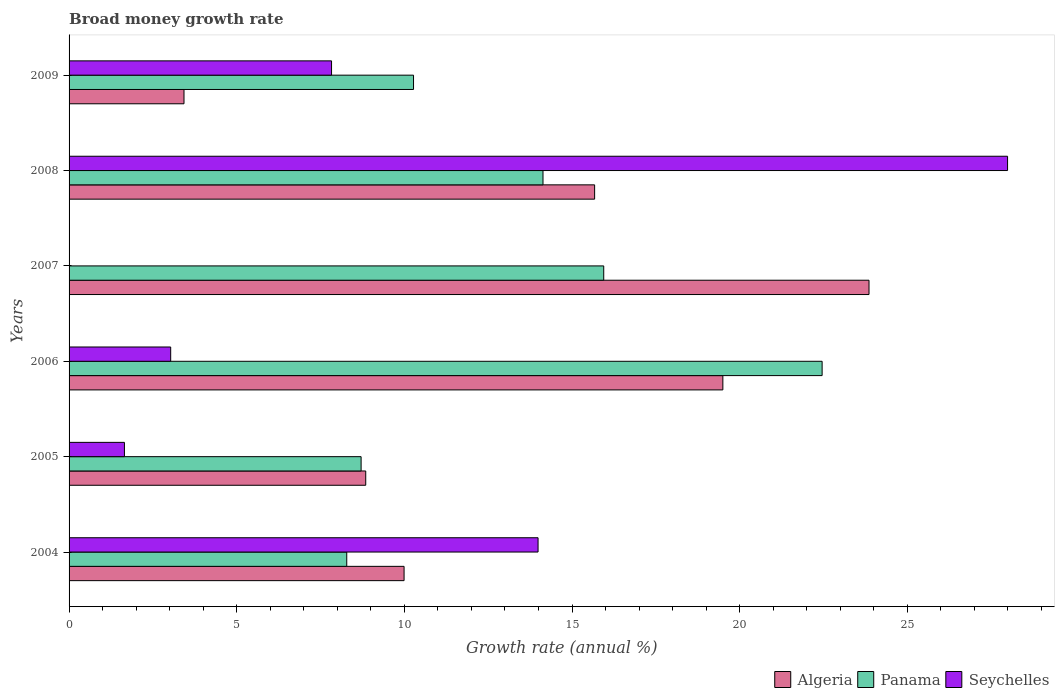How many different coloured bars are there?
Provide a succinct answer. 3. Are the number of bars per tick equal to the number of legend labels?
Your response must be concise. No. How many bars are there on the 3rd tick from the top?
Provide a succinct answer. 2. How many bars are there on the 4th tick from the bottom?
Provide a succinct answer. 2. What is the growth rate in Algeria in 2008?
Your answer should be very brief. 15.67. Across all years, what is the maximum growth rate in Panama?
Give a very brief answer. 22.46. Across all years, what is the minimum growth rate in Seychelles?
Your answer should be compact. 0. In which year was the growth rate in Panama maximum?
Ensure brevity in your answer.  2006. What is the total growth rate in Panama in the graph?
Ensure brevity in your answer.  79.8. What is the difference between the growth rate in Algeria in 2005 and that in 2009?
Offer a terse response. 5.42. What is the difference between the growth rate in Algeria in 2005 and the growth rate in Seychelles in 2007?
Your answer should be very brief. 8.85. What is the average growth rate in Panama per year?
Keep it short and to the point. 13.3. In the year 2005, what is the difference between the growth rate in Seychelles and growth rate in Algeria?
Ensure brevity in your answer.  -7.2. What is the ratio of the growth rate in Algeria in 2004 to that in 2007?
Make the answer very short. 0.42. Is the growth rate in Seychelles in 2004 less than that in 2009?
Your response must be concise. No. Is the difference between the growth rate in Seychelles in 2004 and 2005 greater than the difference between the growth rate in Algeria in 2004 and 2005?
Your answer should be compact. Yes. What is the difference between the highest and the second highest growth rate in Panama?
Your answer should be very brief. 6.51. What is the difference between the highest and the lowest growth rate in Algeria?
Your answer should be very brief. 20.43. Is it the case that in every year, the sum of the growth rate in Seychelles and growth rate in Panama is greater than the growth rate in Algeria?
Keep it short and to the point. No. Are all the bars in the graph horizontal?
Your answer should be compact. Yes. How many years are there in the graph?
Your answer should be very brief. 6. Are the values on the major ticks of X-axis written in scientific E-notation?
Offer a terse response. No. Does the graph contain any zero values?
Offer a very short reply. Yes. How are the legend labels stacked?
Keep it short and to the point. Horizontal. What is the title of the graph?
Offer a terse response. Broad money growth rate. What is the label or title of the X-axis?
Keep it short and to the point. Growth rate (annual %). What is the Growth rate (annual %) of Algeria in 2004?
Your response must be concise. 9.99. What is the Growth rate (annual %) in Panama in 2004?
Your answer should be compact. 8.28. What is the Growth rate (annual %) in Seychelles in 2004?
Your answer should be very brief. 13.99. What is the Growth rate (annual %) of Algeria in 2005?
Keep it short and to the point. 8.85. What is the Growth rate (annual %) in Panama in 2005?
Your response must be concise. 8.71. What is the Growth rate (annual %) of Seychelles in 2005?
Provide a short and direct response. 1.65. What is the Growth rate (annual %) of Algeria in 2006?
Provide a short and direct response. 19.5. What is the Growth rate (annual %) of Panama in 2006?
Your answer should be compact. 22.46. What is the Growth rate (annual %) of Seychelles in 2006?
Your response must be concise. 3.03. What is the Growth rate (annual %) in Algeria in 2007?
Ensure brevity in your answer.  23.86. What is the Growth rate (annual %) in Panama in 2007?
Keep it short and to the point. 15.95. What is the Growth rate (annual %) in Seychelles in 2007?
Offer a terse response. 0. What is the Growth rate (annual %) in Algeria in 2008?
Offer a terse response. 15.67. What is the Growth rate (annual %) in Panama in 2008?
Your answer should be very brief. 14.13. What is the Growth rate (annual %) in Seychelles in 2008?
Your answer should be compact. 27.99. What is the Growth rate (annual %) in Algeria in 2009?
Your answer should be very brief. 3.43. What is the Growth rate (annual %) of Panama in 2009?
Make the answer very short. 10.27. What is the Growth rate (annual %) of Seychelles in 2009?
Offer a terse response. 7.83. Across all years, what is the maximum Growth rate (annual %) in Algeria?
Give a very brief answer. 23.86. Across all years, what is the maximum Growth rate (annual %) of Panama?
Keep it short and to the point. 22.46. Across all years, what is the maximum Growth rate (annual %) in Seychelles?
Make the answer very short. 27.99. Across all years, what is the minimum Growth rate (annual %) in Algeria?
Your response must be concise. 3.43. Across all years, what is the minimum Growth rate (annual %) in Panama?
Give a very brief answer. 8.28. Across all years, what is the minimum Growth rate (annual %) of Seychelles?
Provide a succinct answer. 0. What is the total Growth rate (annual %) of Algeria in the graph?
Make the answer very short. 81.29. What is the total Growth rate (annual %) in Panama in the graph?
Ensure brevity in your answer.  79.8. What is the total Growth rate (annual %) in Seychelles in the graph?
Your answer should be compact. 54.49. What is the difference between the Growth rate (annual %) of Algeria in 2004 and that in 2005?
Offer a very short reply. 1.14. What is the difference between the Growth rate (annual %) in Panama in 2004 and that in 2005?
Keep it short and to the point. -0.43. What is the difference between the Growth rate (annual %) in Seychelles in 2004 and that in 2005?
Ensure brevity in your answer.  12.34. What is the difference between the Growth rate (annual %) of Algeria in 2004 and that in 2006?
Keep it short and to the point. -9.51. What is the difference between the Growth rate (annual %) of Panama in 2004 and that in 2006?
Keep it short and to the point. -14.18. What is the difference between the Growth rate (annual %) of Seychelles in 2004 and that in 2006?
Your response must be concise. 10.96. What is the difference between the Growth rate (annual %) in Algeria in 2004 and that in 2007?
Your response must be concise. -13.87. What is the difference between the Growth rate (annual %) of Panama in 2004 and that in 2007?
Keep it short and to the point. -7.66. What is the difference between the Growth rate (annual %) of Algeria in 2004 and that in 2008?
Make the answer very short. -5.68. What is the difference between the Growth rate (annual %) of Panama in 2004 and that in 2008?
Provide a short and direct response. -5.85. What is the difference between the Growth rate (annual %) in Seychelles in 2004 and that in 2008?
Offer a terse response. -14. What is the difference between the Growth rate (annual %) of Algeria in 2004 and that in 2009?
Keep it short and to the point. 6.56. What is the difference between the Growth rate (annual %) of Panama in 2004 and that in 2009?
Make the answer very short. -1.99. What is the difference between the Growth rate (annual %) of Seychelles in 2004 and that in 2009?
Provide a short and direct response. 6.16. What is the difference between the Growth rate (annual %) in Algeria in 2005 and that in 2006?
Your answer should be very brief. -10.65. What is the difference between the Growth rate (annual %) of Panama in 2005 and that in 2006?
Provide a short and direct response. -13.75. What is the difference between the Growth rate (annual %) of Seychelles in 2005 and that in 2006?
Provide a succinct answer. -1.38. What is the difference between the Growth rate (annual %) of Algeria in 2005 and that in 2007?
Offer a very short reply. -15.01. What is the difference between the Growth rate (annual %) of Panama in 2005 and that in 2007?
Your answer should be compact. -7.24. What is the difference between the Growth rate (annual %) of Algeria in 2005 and that in 2008?
Ensure brevity in your answer.  -6.83. What is the difference between the Growth rate (annual %) in Panama in 2005 and that in 2008?
Give a very brief answer. -5.42. What is the difference between the Growth rate (annual %) of Seychelles in 2005 and that in 2008?
Ensure brevity in your answer.  -26.34. What is the difference between the Growth rate (annual %) in Algeria in 2005 and that in 2009?
Offer a terse response. 5.42. What is the difference between the Growth rate (annual %) of Panama in 2005 and that in 2009?
Your answer should be very brief. -1.56. What is the difference between the Growth rate (annual %) in Seychelles in 2005 and that in 2009?
Keep it short and to the point. -6.18. What is the difference between the Growth rate (annual %) of Algeria in 2006 and that in 2007?
Your response must be concise. -4.36. What is the difference between the Growth rate (annual %) of Panama in 2006 and that in 2007?
Your answer should be compact. 6.51. What is the difference between the Growth rate (annual %) of Algeria in 2006 and that in 2008?
Your answer should be compact. 3.82. What is the difference between the Growth rate (annual %) in Panama in 2006 and that in 2008?
Offer a very short reply. 8.32. What is the difference between the Growth rate (annual %) of Seychelles in 2006 and that in 2008?
Your answer should be very brief. -24.96. What is the difference between the Growth rate (annual %) of Algeria in 2006 and that in 2009?
Your answer should be compact. 16.07. What is the difference between the Growth rate (annual %) in Panama in 2006 and that in 2009?
Ensure brevity in your answer.  12.19. What is the difference between the Growth rate (annual %) in Seychelles in 2006 and that in 2009?
Your answer should be compact. -4.8. What is the difference between the Growth rate (annual %) of Algeria in 2007 and that in 2008?
Your response must be concise. 8.18. What is the difference between the Growth rate (annual %) of Panama in 2007 and that in 2008?
Your response must be concise. 1.81. What is the difference between the Growth rate (annual %) in Algeria in 2007 and that in 2009?
Make the answer very short. 20.43. What is the difference between the Growth rate (annual %) of Panama in 2007 and that in 2009?
Offer a very short reply. 5.67. What is the difference between the Growth rate (annual %) of Algeria in 2008 and that in 2009?
Offer a terse response. 12.25. What is the difference between the Growth rate (annual %) of Panama in 2008 and that in 2009?
Your answer should be compact. 3.86. What is the difference between the Growth rate (annual %) in Seychelles in 2008 and that in 2009?
Give a very brief answer. 20.16. What is the difference between the Growth rate (annual %) of Algeria in 2004 and the Growth rate (annual %) of Panama in 2005?
Your answer should be compact. 1.28. What is the difference between the Growth rate (annual %) in Algeria in 2004 and the Growth rate (annual %) in Seychelles in 2005?
Keep it short and to the point. 8.34. What is the difference between the Growth rate (annual %) of Panama in 2004 and the Growth rate (annual %) of Seychelles in 2005?
Your answer should be very brief. 6.63. What is the difference between the Growth rate (annual %) in Algeria in 2004 and the Growth rate (annual %) in Panama in 2006?
Provide a short and direct response. -12.47. What is the difference between the Growth rate (annual %) in Algeria in 2004 and the Growth rate (annual %) in Seychelles in 2006?
Give a very brief answer. 6.96. What is the difference between the Growth rate (annual %) of Panama in 2004 and the Growth rate (annual %) of Seychelles in 2006?
Offer a terse response. 5.25. What is the difference between the Growth rate (annual %) of Algeria in 2004 and the Growth rate (annual %) of Panama in 2007?
Your answer should be very brief. -5.95. What is the difference between the Growth rate (annual %) in Algeria in 2004 and the Growth rate (annual %) in Panama in 2008?
Make the answer very short. -4.14. What is the difference between the Growth rate (annual %) of Algeria in 2004 and the Growth rate (annual %) of Seychelles in 2008?
Your response must be concise. -18. What is the difference between the Growth rate (annual %) in Panama in 2004 and the Growth rate (annual %) in Seychelles in 2008?
Keep it short and to the point. -19.71. What is the difference between the Growth rate (annual %) of Algeria in 2004 and the Growth rate (annual %) of Panama in 2009?
Ensure brevity in your answer.  -0.28. What is the difference between the Growth rate (annual %) in Algeria in 2004 and the Growth rate (annual %) in Seychelles in 2009?
Your answer should be compact. 2.16. What is the difference between the Growth rate (annual %) of Panama in 2004 and the Growth rate (annual %) of Seychelles in 2009?
Your answer should be very brief. 0.45. What is the difference between the Growth rate (annual %) in Algeria in 2005 and the Growth rate (annual %) in Panama in 2006?
Make the answer very short. -13.61. What is the difference between the Growth rate (annual %) of Algeria in 2005 and the Growth rate (annual %) of Seychelles in 2006?
Make the answer very short. 5.82. What is the difference between the Growth rate (annual %) of Panama in 2005 and the Growth rate (annual %) of Seychelles in 2006?
Provide a short and direct response. 5.68. What is the difference between the Growth rate (annual %) of Algeria in 2005 and the Growth rate (annual %) of Panama in 2007?
Keep it short and to the point. -7.1. What is the difference between the Growth rate (annual %) of Algeria in 2005 and the Growth rate (annual %) of Panama in 2008?
Offer a terse response. -5.29. What is the difference between the Growth rate (annual %) of Algeria in 2005 and the Growth rate (annual %) of Seychelles in 2008?
Ensure brevity in your answer.  -19.14. What is the difference between the Growth rate (annual %) in Panama in 2005 and the Growth rate (annual %) in Seychelles in 2008?
Offer a very short reply. -19.28. What is the difference between the Growth rate (annual %) in Algeria in 2005 and the Growth rate (annual %) in Panama in 2009?
Make the answer very short. -1.43. What is the difference between the Growth rate (annual %) in Algeria in 2005 and the Growth rate (annual %) in Seychelles in 2009?
Offer a very short reply. 1.02. What is the difference between the Growth rate (annual %) in Panama in 2005 and the Growth rate (annual %) in Seychelles in 2009?
Keep it short and to the point. 0.88. What is the difference between the Growth rate (annual %) in Algeria in 2006 and the Growth rate (annual %) in Panama in 2007?
Give a very brief answer. 3.55. What is the difference between the Growth rate (annual %) of Algeria in 2006 and the Growth rate (annual %) of Panama in 2008?
Offer a terse response. 5.36. What is the difference between the Growth rate (annual %) in Algeria in 2006 and the Growth rate (annual %) in Seychelles in 2008?
Your answer should be very brief. -8.49. What is the difference between the Growth rate (annual %) in Panama in 2006 and the Growth rate (annual %) in Seychelles in 2008?
Ensure brevity in your answer.  -5.53. What is the difference between the Growth rate (annual %) in Algeria in 2006 and the Growth rate (annual %) in Panama in 2009?
Your answer should be very brief. 9.23. What is the difference between the Growth rate (annual %) of Algeria in 2006 and the Growth rate (annual %) of Seychelles in 2009?
Keep it short and to the point. 11.67. What is the difference between the Growth rate (annual %) of Panama in 2006 and the Growth rate (annual %) of Seychelles in 2009?
Your response must be concise. 14.63. What is the difference between the Growth rate (annual %) of Algeria in 2007 and the Growth rate (annual %) of Panama in 2008?
Provide a short and direct response. 9.72. What is the difference between the Growth rate (annual %) of Algeria in 2007 and the Growth rate (annual %) of Seychelles in 2008?
Your response must be concise. -4.13. What is the difference between the Growth rate (annual %) in Panama in 2007 and the Growth rate (annual %) in Seychelles in 2008?
Make the answer very short. -12.04. What is the difference between the Growth rate (annual %) in Algeria in 2007 and the Growth rate (annual %) in Panama in 2009?
Make the answer very short. 13.58. What is the difference between the Growth rate (annual %) of Algeria in 2007 and the Growth rate (annual %) of Seychelles in 2009?
Your answer should be very brief. 16.03. What is the difference between the Growth rate (annual %) of Panama in 2007 and the Growth rate (annual %) of Seychelles in 2009?
Ensure brevity in your answer.  8.12. What is the difference between the Growth rate (annual %) of Algeria in 2008 and the Growth rate (annual %) of Panama in 2009?
Your answer should be compact. 5.4. What is the difference between the Growth rate (annual %) in Algeria in 2008 and the Growth rate (annual %) in Seychelles in 2009?
Your answer should be compact. 7.85. What is the difference between the Growth rate (annual %) of Panama in 2008 and the Growth rate (annual %) of Seychelles in 2009?
Provide a succinct answer. 6.31. What is the average Growth rate (annual %) in Algeria per year?
Your response must be concise. 13.55. What is the average Growth rate (annual %) in Panama per year?
Keep it short and to the point. 13.3. What is the average Growth rate (annual %) of Seychelles per year?
Offer a terse response. 9.08. In the year 2004, what is the difference between the Growth rate (annual %) in Algeria and Growth rate (annual %) in Panama?
Provide a short and direct response. 1.71. In the year 2004, what is the difference between the Growth rate (annual %) in Algeria and Growth rate (annual %) in Seychelles?
Your answer should be compact. -4. In the year 2004, what is the difference between the Growth rate (annual %) of Panama and Growth rate (annual %) of Seychelles?
Your answer should be very brief. -5.71. In the year 2005, what is the difference between the Growth rate (annual %) of Algeria and Growth rate (annual %) of Panama?
Provide a short and direct response. 0.14. In the year 2005, what is the difference between the Growth rate (annual %) of Algeria and Growth rate (annual %) of Seychelles?
Your answer should be very brief. 7.2. In the year 2005, what is the difference between the Growth rate (annual %) of Panama and Growth rate (annual %) of Seychelles?
Your answer should be very brief. 7.06. In the year 2006, what is the difference between the Growth rate (annual %) in Algeria and Growth rate (annual %) in Panama?
Your answer should be compact. -2.96. In the year 2006, what is the difference between the Growth rate (annual %) of Algeria and Growth rate (annual %) of Seychelles?
Provide a short and direct response. 16.47. In the year 2006, what is the difference between the Growth rate (annual %) in Panama and Growth rate (annual %) in Seychelles?
Make the answer very short. 19.43. In the year 2007, what is the difference between the Growth rate (annual %) in Algeria and Growth rate (annual %) in Panama?
Provide a succinct answer. 7.91. In the year 2008, what is the difference between the Growth rate (annual %) of Algeria and Growth rate (annual %) of Panama?
Make the answer very short. 1.54. In the year 2008, what is the difference between the Growth rate (annual %) of Algeria and Growth rate (annual %) of Seychelles?
Your answer should be compact. -12.31. In the year 2008, what is the difference between the Growth rate (annual %) of Panama and Growth rate (annual %) of Seychelles?
Make the answer very short. -13.86. In the year 2009, what is the difference between the Growth rate (annual %) in Algeria and Growth rate (annual %) in Panama?
Your answer should be very brief. -6.85. In the year 2009, what is the difference between the Growth rate (annual %) of Algeria and Growth rate (annual %) of Seychelles?
Give a very brief answer. -4.4. In the year 2009, what is the difference between the Growth rate (annual %) in Panama and Growth rate (annual %) in Seychelles?
Provide a succinct answer. 2.44. What is the ratio of the Growth rate (annual %) in Algeria in 2004 to that in 2005?
Offer a terse response. 1.13. What is the ratio of the Growth rate (annual %) of Panama in 2004 to that in 2005?
Your answer should be very brief. 0.95. What is the ratio of the Growth rate (annual %) in Seychelles in 2004 to that in 2005?
Your answer should be compact. 8.47. What is the ratio of the Growth rate (annual %) of Algeria in 2004 to that in 2006?
Your answer should be compact. 0.51. What is the ratio of the Growth rate (annual %) in Panama in 2004 to that in 2006?
Make the answer very short. 0.37. What is the ratio of the Growth rate (annual %) of Seychelles in 2004 to that in 2006?
Offer a terse response. 4.62. What is the ratio of the Growth rate (annual %) of Algeria in 2004 to that in 2007?
Offer a very short reply. 0.42. What is the ratio of the Growth rate (annual %) of Panama in 2004 to that in 2007?
Provide a short and direct response. 0.52. What is the ratio of the Growth rate (annual %) in Algeria in 2004 to that in 2008?
Give a very brief answer. 0.64. What is the ratio of the Growth rate (annual %) in Panama in 2004 to that in 2008?
Keep it short and to the point. 0.59. What is the ratio of the Growth rate (annual %) in Seychelles in 2004 to that in 2008?
Offer a terse response. 0.5. What is the ratio of the Growth rate (annual %) of Algeria in 2004 to that in 2009?
Give a very brief answer. 2.91. What is the ratio of the Growth rate (annual %) in Panama in 2004 to that in 2009?
Your answer should be very brief. 0.81. What is the ratio of the Growth rate (annual %) in Seychelles in 2004 to that in 2009?
Give a very brief answer. 1.79. What is the ratio of the Growth rate (annual %) of Algeria in 2005 to that in 2006?
Your response must be concise. 0.45. What is the ratio of the Growth rate (annual %) in Panama in 2005 to that in 2006?
Offer a very short reply. 0.39. What is the ratio of the Growth rate (annual %) in Seychelles in 2005 to that in 2006?
Offer a very short reply. 0.54. What is the ratio of the Growth rate (annual %) in Algeria in 2005 to that in 2007?
Ensure brevity in your answer.  0.37. What is the ratio of the Growth rate (annual %) in Panama in 2005 to that in 2007?
Provide a short and direct response. 0.55. What is the ratio of the Growth rate (annual %) of Algeria in 2005 to that in 2008?
Offer a very short reply. 0.56. What is the ratio of the Growth rate (annual %) of Panama in 2005 to that in 2008?
Ensure brevity in your answer.  0.62. What is the ratio of the Growth rate (annual %) in Seychelles in 2005 to that in 2008?
Make the answer very short. 0.06. What is the ratio of the Growth rate (annual %) in Algeria in 2005 to that in 2009?
Make the answer very short. 2.58. What is the ratio of the Growth rate (annual %) of Panama in 2005 to that in 2009?
Keep it short and to the point. 0.85. What is the ratio of the Growth rate (annual %) in Seychelles in 2005 to that in 2009?
Offer a terse response. 0.21. What is the ratio of the Growth rate (annual %) of Algeria in 2006 to that in 2007?
Ensure brevity in your answer.  0.82. What is the ratio of the Growth rate (annual %) of Panama in 2006 to that in 2007?
Your answer should be compact. 1.41. What is the ratio of the Growth rate (annual %) of Algeria in 2006 to that in 2008?
Give a very brief answer. 1.24. What is the ratio of the Growth rate (annual %) in Panama in 2006 to that in 2008?
Ensure brevity in your answer.  1.59. What is the ratio of the Growth rate (annual %) in Seychelles in 2006 to that in 2008?
Make the answer very short. 0.11. What is the ratio of the Growth rate (annual %) in Algeria in 2006 to that in 2009?
Ensure brevity in your answer.  5.69. What is the ratio of the Growth rate (annual %) of Panama in 2006 to that in 2009?
Provide a short and direct response. 2.19. What is the ratio of the Growth rate (annual %) of Seychelles in 2006 to that in 2009?
Offer a very short reply. 0.39. What is the ratio of the Growth rate (annual %) of Algeria in 2007 to that in 2008?
Ensure brevity in your answer.  1.52. What is the ratio of the Growth rate (annual %) in Panama in 2007 to that in 2008?
Offer a very short reply. 1.13. What is the ratio of the Growth rate (annual %) in Algeria in 2007 to that in 2009?
Your answer should be compact. 6.96. What is the ratio of the Growth rate (annual %) of Panama in 2007 to that in 2009?
Your answer should be compact. 1.55. What is the ratio of the Growth rate (annual %) of Algeria in 2008 to that in 2009?
Your response must be concise. 4.57. What is the ratio of the Growth rate (annual %) in Panama in 2008 to that in 2009?
Make the answer very short. 1.38. What is the ratio of the Growth rate (annual %) of Seychelles in 2008 to that in 2009?
Offer a terse response. 3.58. What is the difference between the highest and the second highest Growth rate (annual %) of Algeria?
Your response must be concise. 4.36. What is the difference between the highest and the second highest Growth rate (annual %) of Panama?
Make the answer very short. 6.51. What is the difference between the highest and the second highest Growth rate (annual %) in Seychelles?
Keep it short and to the point. 14. What is the difference between the highest and the lowest Growth rate (annual %) of Algeria?
Your answer should be very brief. 20.43. What is the difference between the highest and the lowest Growth rate (annual %) of Panama?
Keep it short and to the point. 14.18. What is the difference between the highest and the lowest Growth rate (annual %) in Seychelles?
Give a very brief answer. 27.99. 